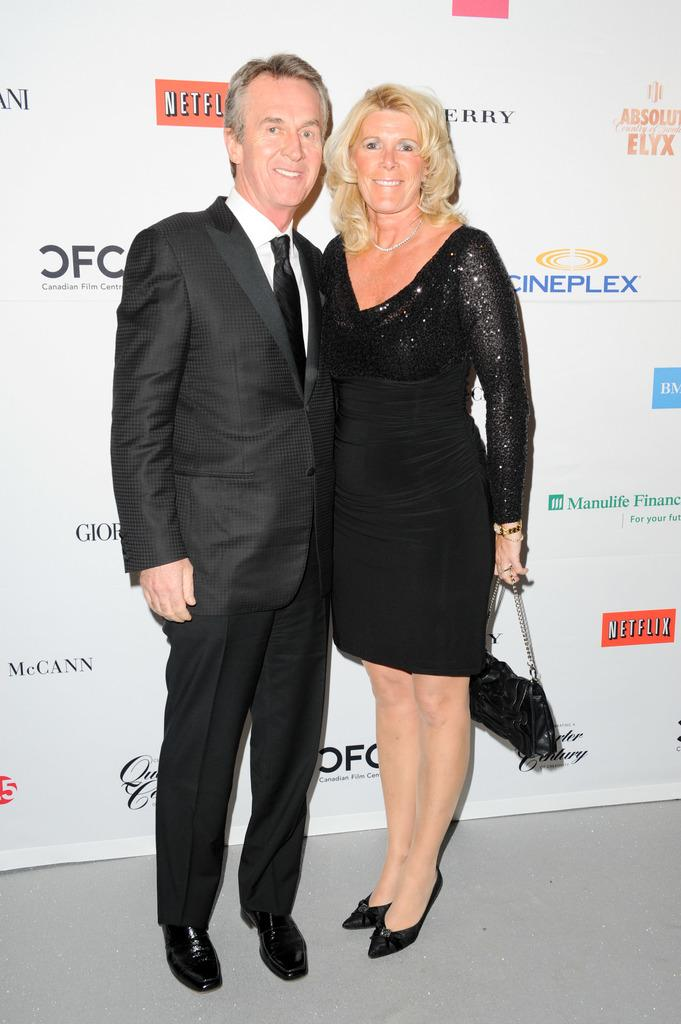How many people are in the image? There are two persons in the image. What color are the dresses of the people in the image? Both persons are wearing black color dress. Can you identify the gender of one of the persons? Yes, one of the persons is a lady. What is the lady holding in the image? The lady is holding a handbag. What can be seen in the background of the image? There is a board in the background of the image. What type of soap is the lady using in the image? There is no soap present in the image. What subject is being taught in the class visible in the image? There is no class visible in the image; it only features two people and a board in the background. 